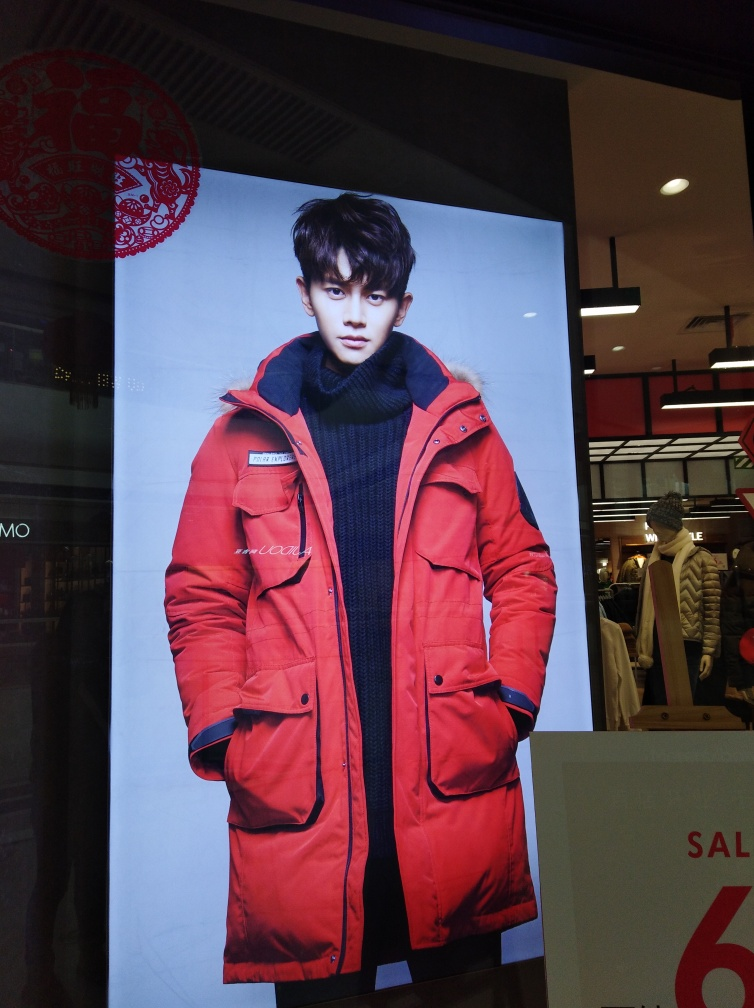What possible message or feeling is the advertisement trying to convey? The advertisement likely aims to evoke a sense of fashion-forward, bold confidence through the model's stance and the vibrant color of the attire, appealing to a young and urban demographic. 